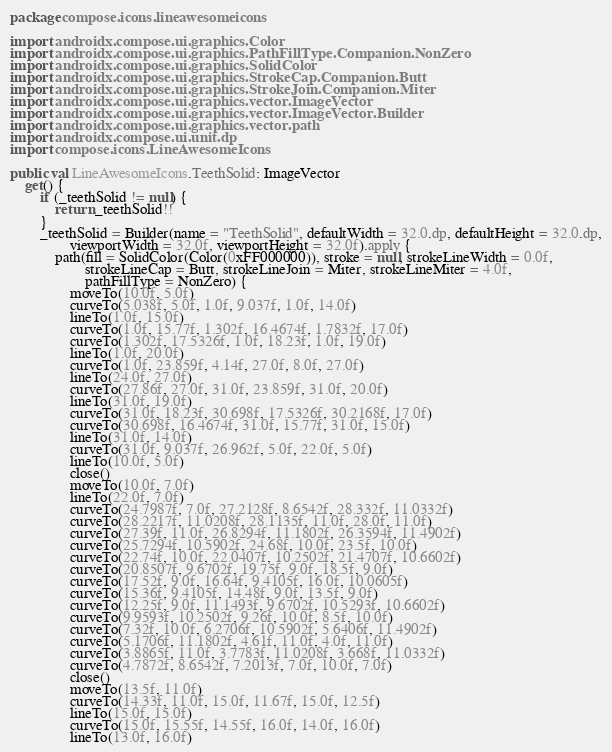<code> <loc_0><loc_0><loc_500><loc_500><_Kotlin_>package compose.icons.lineawesomeicons

import androidx.compose.ui.graphics.Color
import androidx.compose.ui.graphics.PathFillType.Companion.NonZero
import androidx.compose.ui.graphics.SolidColor
import androidx.compose.ui.graphics.StrokeCap.Companion.Butt
import androidx.compose.ui.graphics.StrokeJoin.Companion.Miter
import androidx.compose.ui.graphics.vector.ImageVector
import androidx.compose.ui.graphics.vector.ImageVector.Builder
import androidx.compose.ui.graphics.vector.path
import androidx.compose.ui.unit.dp
import compose.icons.LineAwesomeIcons

public val LineAwesomeIcons.TeethSolid: ImageVector
    get() {
        if (_teethSolid != null) {
            return _teethSolid!!
        }
        _teethSolid = Builder(name = "TeethSolid", defaultWidth = 32.0.dp, defaultHeight = 32.0.dp,
                viewportWidth = 32.0f, viewportHeight = 32.0f).apply {
            path(fill = SolidColor(Color(0xFF000000)), stroke = null, strokeLineWidth = 0.0f,
                    strokeLineCap = Butt, strokeLineJoin = Miter, strokeLineMiter = 4.0f,
                    pathFillType = NonZero) {
                moveTo(10.0f, 5.0f)
                curveTo(5.038f, 5.0f, 1.0f, 9.037f, 1.0f, 14.0f)
                lineTo(1.0f, 15.0f)
                curveTo(1.0f, 15.77f, 1.302f, 16.4674f, 1.7832f, 17.0f)
                curveTo(1.302f, 17.5326f, 1.0f, 18.23f, 1.0f, 19.0f)
                lineTo(1.0f, 20.0f)
                curveTo(1.0f, 23.859f, 4.14f, 27.0f, 8.0f, 27.0f)
                lineTo(24.0f, 27.0f)
                curveTo(27.86f, 27.0f, 31.0f, 23.859f, 31.0f, 20.0f)
                lineTo(31.0f, 19.0f)
                curveTo(31.0f, 18.23f, 30.698f, 17.5326f, 30.2168f, 17.0f)
                curveTo(30.698f, 16.4674f, 31.0f, 15.77f, 31.0f, 15.0f)
                lineTo(31.0f, 14.0f)
                curveTo(31.0f, 9.037f, 26.962f, 5.0f, 22.0f, 5.0f)
                lineTo(10.0f, 5.0f)
                close()
                moveTo(10.0f, 7.0f)
                lineTo(22.0f, 7.0f)
                curveTo(24.7987f, 7.0f, 27.2128f, 8.6542f, 28.332f, 11.0332f)
                curveTo(28.2217f, 11.0208f, 28.1135f, 11.0f, 28.0f, 11.0f)
                curveTo(27.39f, 11.0f, 26.8294f, 11.1802f, 26.3594f, 11.4902f)
                curveTo(25.7294f, 10.5902f, 24.68f, 10.0f, 23.5f, 10.0f)
                curveTo(22.74f, 10.0f, 22.0407f, 10.2502f, 21.4707f, 10.6602f)
                curveTo(20.8507f, 9.6702f, 19.75f, 9.0f, 18.5f, 9.0f)
                curveTo(17.52f, 9.0f, 16.64f, 9.4105f, 16.0f, 10.0605f)
                curveTo(15.36f, 9.4105f, 14.48f, 9.0f, 13.5f, 9.0f)
                curveTo(12.25f, 9.0f, 11.1493f, 9.6702f, 10.5293f, 10.6602f)
                curveTo(9.9593f, 10.2502f, 9.26f, 10.0f, 8.5f, 10.0f)
                curveTo(7.32f, 10.0f, 6.2706f, 10.5902f, 5.6406f, 11.4902f)
                curveTo(5.1706f, 11.1802f, 4.61f, 11.0f, 4.0f, 11.0f)
                curveTo(3.8865f, 11.0f, 3.7783f, 11.0208f, 3.668f, 11.0332f)
                curveTo(4.7872f, 8.6542f, 7.2013f, 7.0f, 10.0f, 7.0f)
                close()
                moveTo(13.5f, 11.0f)
                curveTo(14.33f, 11.0f, 15.0f, 11.67f, 15.0f, 12.5f)
                lineTo(15.0f, 15.0f)
                curveTo(15.0f, 15.55f, 14.55f, 16.0f, 14.0f, 16.0f)
                lineTo(13.0f, 16.0f)</code> 